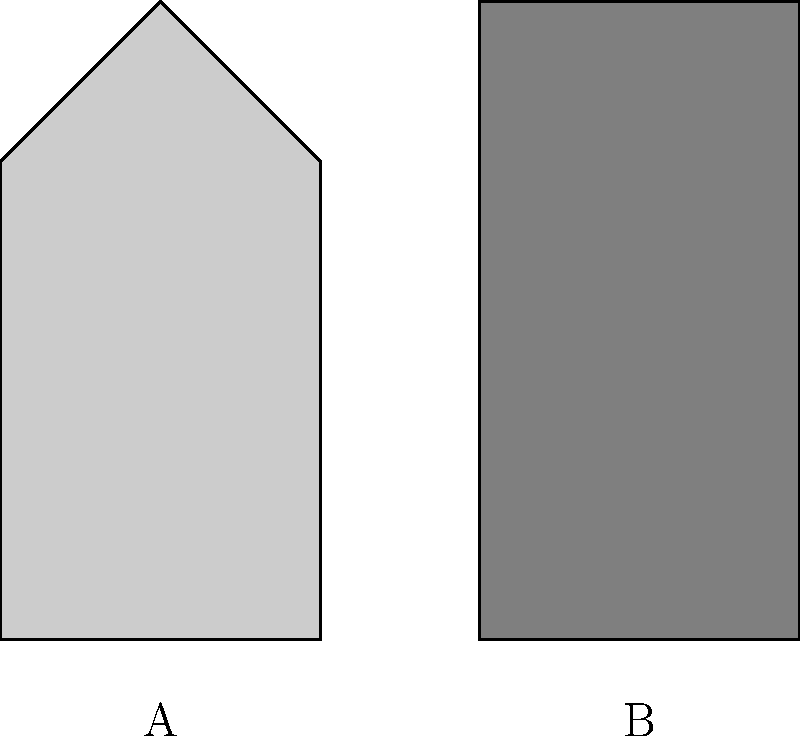Examine the silhouettes A and B. Which architectural style does silhouette B most likely represent, and how does its form embody the principles of that movement? 1. Silhouette analysis:
   A: Complex form with pitched roof, reminiscent of traditional architecture.
   B: Simple, rectangular form with flat roof, indicative of modernist design.

2. Modernist principles in silhouette B:
   a. Form follows function: The clean, unadorned shape suggests a focus on utility.
   b. Rejection of ornamentation: No decorative elements are visible in the silhouette.
   c. Emphasis on geometric forms: The building is a pure rectangle, embodying modernist ideals.
   d. Flat roof: A hallmark of modernist architecture, contrasting with traditional pitched roofs.

3. Historical context:
   Modernist architecture emerged in the early 20th century, gaining prominence in the mid-20th century.
   It represented a radical departure from traditional architectural styles, emphasizing simplicity and function.

4. Formalist composition:
   The stark contrast between the complex traditional form (A) and the simple modernist form (B) highlights the formalist approach to architectural design in modernism.

5. Avant-garde nature:
   At its inception, modernist architecture was considered avant-garde, challenging established norms and pushing the boundaries of design.
Answer: Modernist; embodies simplicity, functionality, and geometric purity 